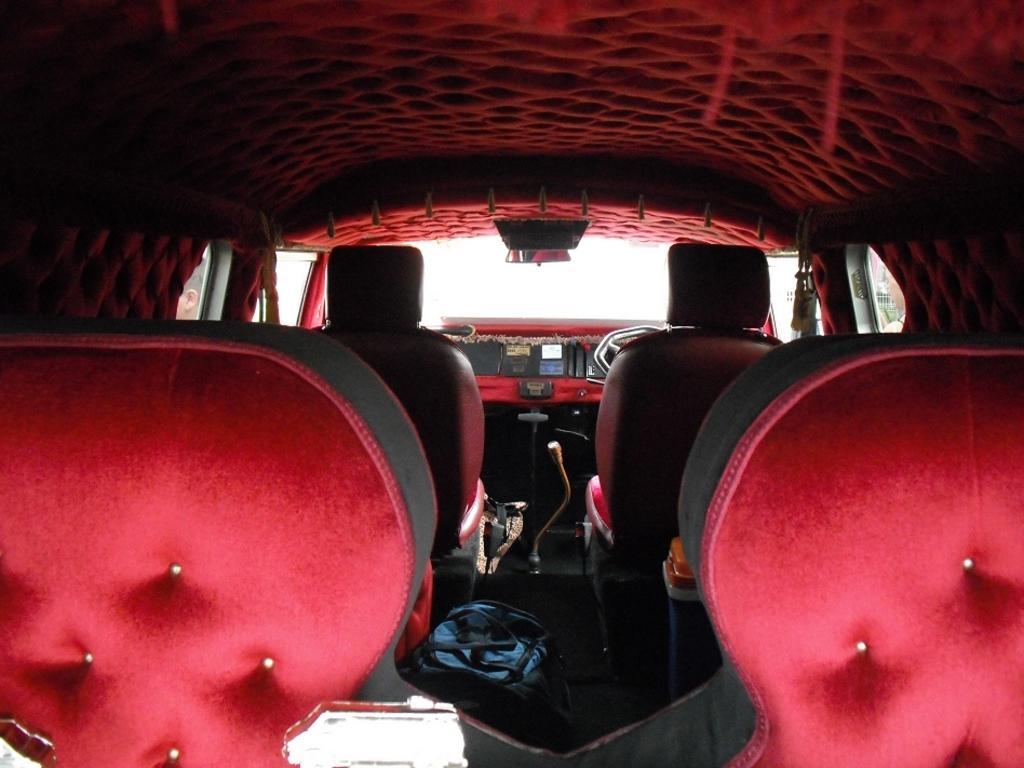How would you summarize this image in a sentence or two? In this image I can see the inner view of the vehicle. Inside the vehicle I can see the seats, bag, gear rod and the steering. To the left I can see the head of the person. And there is a white background. 